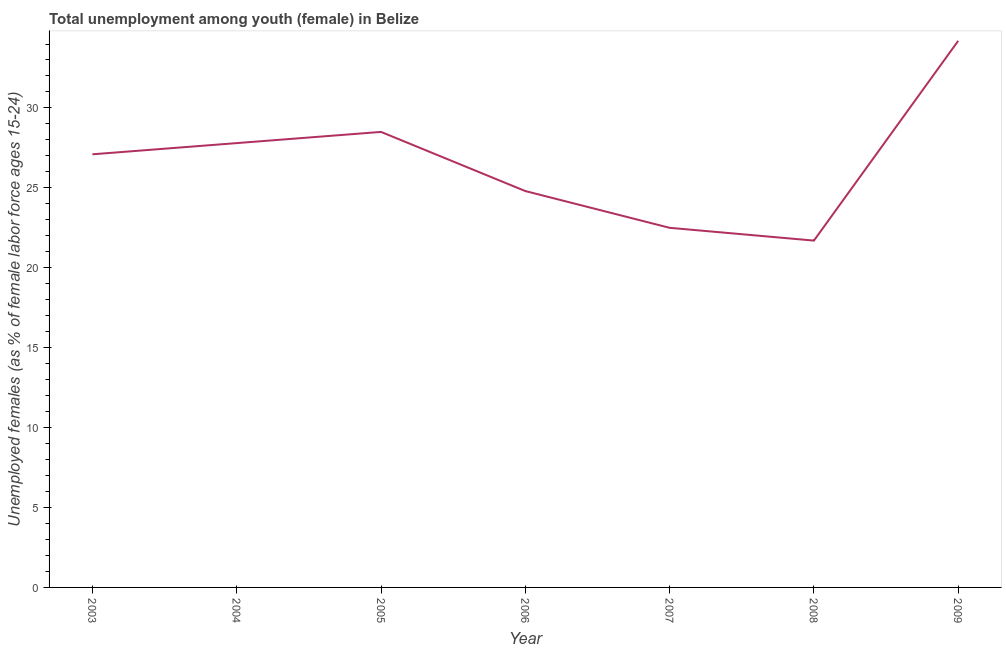Across all years, what is the maximum unemployed female youth population?
Provide a short and direct response. 34.2. Across all years, what is the minimum unemployed female youth population?
Make the answer very short. 21.7. What is the sum of the unemployed female youth population?
Offer a terse response. 186.6. What is the difference between the unemployed female youth population in 2003 and 2005?
Offer a very short reply. -1.4. What is the average unemployed female youth population per year?
Your response must be concise. 26.66. What is the median unemployed female youth population?
Ensure brevity in your answer.  27.1. In how many years, is the unemployed female youth population greater than 20 %?
Ensure brevity in your answer.  7. What is the ratio of the unemployed female youth population in 2006 to that in 2008?
Offer a terse response. 1.14. Is the unemployed female youth population in 2003 less than that in 2004?
Provide a succinct answer. Yes. Is the difference between the unemployed female youth population in 2005 and 2006 greater than the difference between any two years?
Ensure brevity in your answer.  No. What is the difference between the highest and the second highest unemployed female youth population?
Keep it short and to the point. 5.7. What is the difference between the highest and the lowest unemployed female youth population?
Your response must be concise. 12.5. In how many years, is the unemployed female youth population greater than the average unemployed female youth population taken over all years?
Keep it short and to the point. 4. Does the unemployed female youth population monotonically increase over the years?
Give a very brief answer. No. What is the difference between two consecutive major ticks on the Y-axis?
Ensure brevity in your answer.  5. Are the values on the major ticks of Y-axis written in scientific E-notation?
Your answer should be very brief. No. What is the title of the graph?
Keep it short and to the point. Total unemployment among youth (female) in Belize. What is the label or title of the Y-axis?
Your response must be concise. Unemployed females (as % of female labor force ages 15-24). What is the Unemployed females (as % of female labor force ages 15-24) in 2003?
Provide a short and direct response. 27.1. What is the Unemployed females (as % of female labor force ages 15-24) in 2004?
Ensure brevity in your answer.  27.8. What is the Unemployed females (as % of female labor force ages 15-24) of 2006?
Make the answer very short. 24.8. What is the Unemployed females (as % of female labor force ages 15-24) in 2007?
Your answer should be very brief. 22.5. What is the Unemployed females (as % of female labor force ages 15-24) of 2008?
Give a very brief answer. 21.7. What is the Unemployed females (as % of female labor force ages 15-24) in 2009?
Offer a very short reply. 34.2. What is the difference between the Unemployed females (as % of female labor force ages 15-24) in 2003 and 2004?
Keep it short and to the point. -0.7. What is the difference between the Unemployed females (as % of female labor force ages 15-24) in 2003 and 2006?
Offer a terse response. 2.3. What is the difference between the Unemployed females (as % of female labor force ages 15-24) in 2003 and 2008?
Your response must be concise. 5.4. What is the difference between the Unemployed females (as % of female labor force ages 15-24) in 2004 and 2006?
Your response must be concise. 3. What is the difference between the Unemployed females (as % of female labor force ages 15-24) in 2004 and 2007?
Keep it short and to the point. 5.3. What is the difference between the Unemployed females (as % of female labor force ages 15-24) in 2004 and 2008?
Provide a short and direct response. 6.1. What is the difference between the Unemployed females (as % of female labor force ages 15-24) in 2004 and 2009?
Ensure brevity in your answer.  -6.4. What is the difference between the Unemployed females (as % of female labor force ages 15-24) in 2005 and 2006?
Offer a terse response. 3.7. What is the difference between the Unemployed females (as % of female labor force ages 15-24) in 2005 and 2007?
Ensure brevity in your answer.  6. What is the difference between the Unemployed females (as % of female labor force ages 15-24) in 2006 and 2009?
Provide a short and direct response. -9.4. What is the difference between the Unemployed females (as % of female labor force ages 15-24) in 2007 and 2008?
Your answer should be very brief. 0.8. What is the ratio of the Unemployed females (as % of female labor force ages 15-24) in 2003 to that in 2005?
Offer a very short reply. 0.95. What is the ratio of the Unemployed females (as % of female labor force ages 15-24) in 2003 to that in 2006?
Give a very brief answer. 1.09. What is the ratio of the Unemployed females (as % of female labor force ages 15-24) in 2003 to that in 2007?
Give a very brief answer. 1.2. What is the ratio of the Unemployed females (as % of female labor force ages 15-24) in 2003 to that in 2008?
Offer a very short reply. 1.25. What is the ratio of the Unemployed females (as % of female labor force ages 15-24) in 2003 to that in 2009?
Keep it short and to the point. 0.79. What is the ratio of the Unemployed females (as % of female labor force ages 15-24) in 2004 to that in 2006?
Provide a succinct answer. 1.12. What is the ratio of the Unemployed females (as % of female labor force ages 15-24) in 2004 to that in 2007?
Provide a short and direct response. 1.24. What is the ratio of the Unemployed females (as % of female labor force ages 15-24) in 2004 to that in 2008?
Your answer should be compact. 1.28. What is the ratio of the Unemployed females (as % of female labor force ages 15-24) in 2004 to that in 2009?
Make the answer very short. 0.81. What is the ratio of the Unemployed females (as % of female labor force ages 15-24) in 2005 to that in 2006?
Ensure brevity in your answer.  1.15. What is the ratio of the Unemployed females (as % of female labor force ages 15-24) in 2005 to that in 2007?
Ensure brevity in your answer.  1.27. What is the ratio of the Unemployed females (as % of female labor force ages 15-24) in 2005 to that in 2008?
Provide a succinct answer. 1.31. What is the ratio of the Unemployed females (as % of female labor force ages 15-24) in 2005 to that in 2009?
Give a very brief answer. 0.83. What is the ratio of the Unemployed females (as % of female labor force ages 15-24) in 2006 to that in 2007?
Keep it short and to the point. 1.1. What is the ratio of the Unemployed females (as % of female labor force ages 15-24) in 2006 to that in 2008?
Give a very brief answer. 1.14. What is the ratio of the Unemployed females (as % of female labor force ages 15-24) in 2006 to that in 2009?
Offer a very short reply. 0.72. What is the ratio of the Unemployed females (as % of female labor force ages 15-24) in 2007 to that in 2008?
Your response must be concise. 1.04. What is the ratio of the Unemployed females (as % of female labor force ages 15-24) in 2007 to that in 2009?
Offer a terse response. 0.66. What is the ratio of the Unemployed females (as % of female labor force ages 15-24) in 2008 to that in 2009?
Your answer should be very brief. 0.64. 